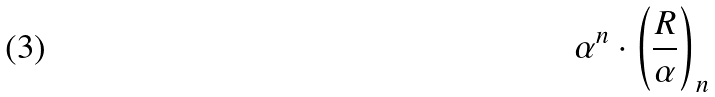<formula> <loc_0><loc_0><loc_500><loc_500>\alpha ^ { n } \cdot \left ( { \frac { R } { \alpha } } \right ) _ { n }</formula> 